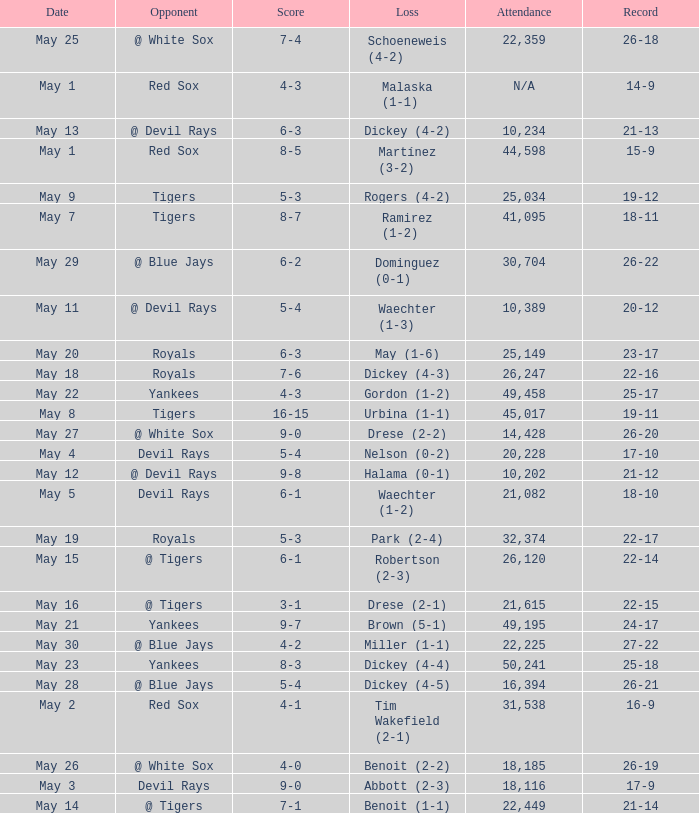What is the score of the game attended by 25,034? 5-3. 